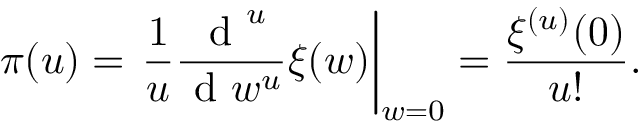Convert formula to latex. <formula><loc_0><loc_0><loc_500><loc_500>\pi ( u ) = \frac { 1 } { u } \frac { d ^ { u } } { d w ^ { u } } \xi ( w ) \right | _ { w = 0 } = \frac { \xi ^ { ( u ) } ( 0 ) } { u ! } .</formula> 